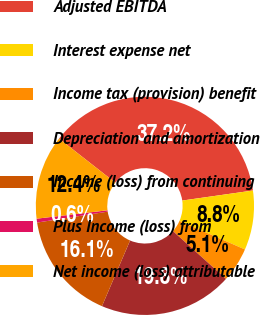Convert chart. <chart><loc_0><loc_0><loc_500><loc_500><pie_chart><fcel>Adjusted EBITDA<fcel>Interest expense net<fcel>Income tax (provision) benefit<fcel>Depreciation and amortization<fcel>Income (loss) from continuing<fcel>Plus Income (loss) from<fcel>Net income (loss) attributable<nl><fcel>37.18%<fcel>8.79%<fcel>5.13%<fcel>19.77%<fcel>16.11%<fcel>0.57%<fcel>12.45%<nl></chart> 